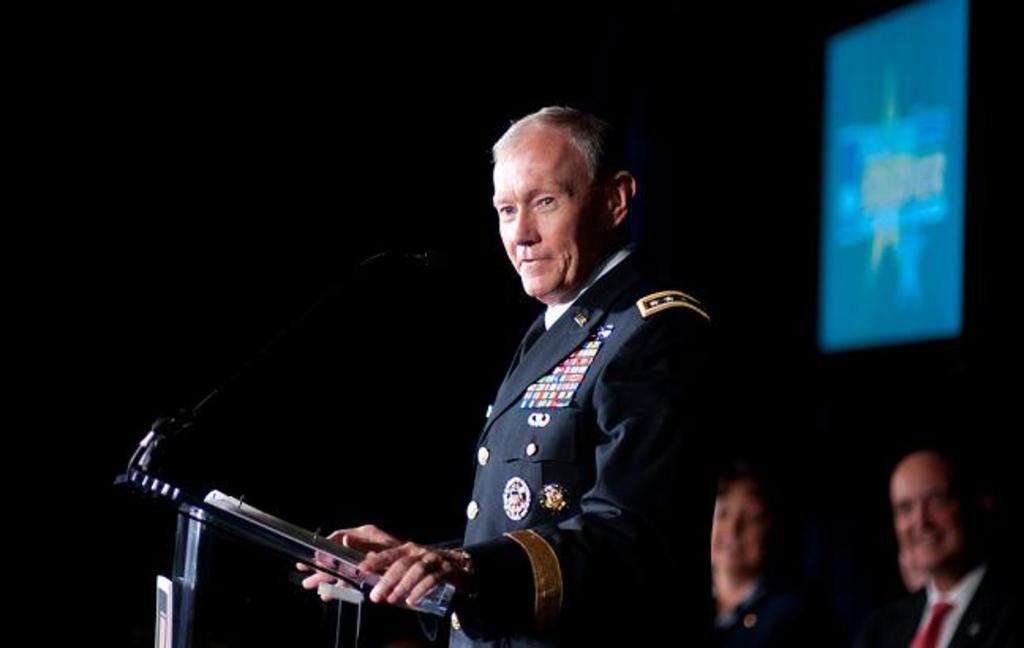Could you give a brief overview of what you see in this image? On the right side, there is a person in a uniform, standing in front of a glass stand, on which there is a mic attached to a stand, there are two other persons and there is a screen. And the background is dark in color. 